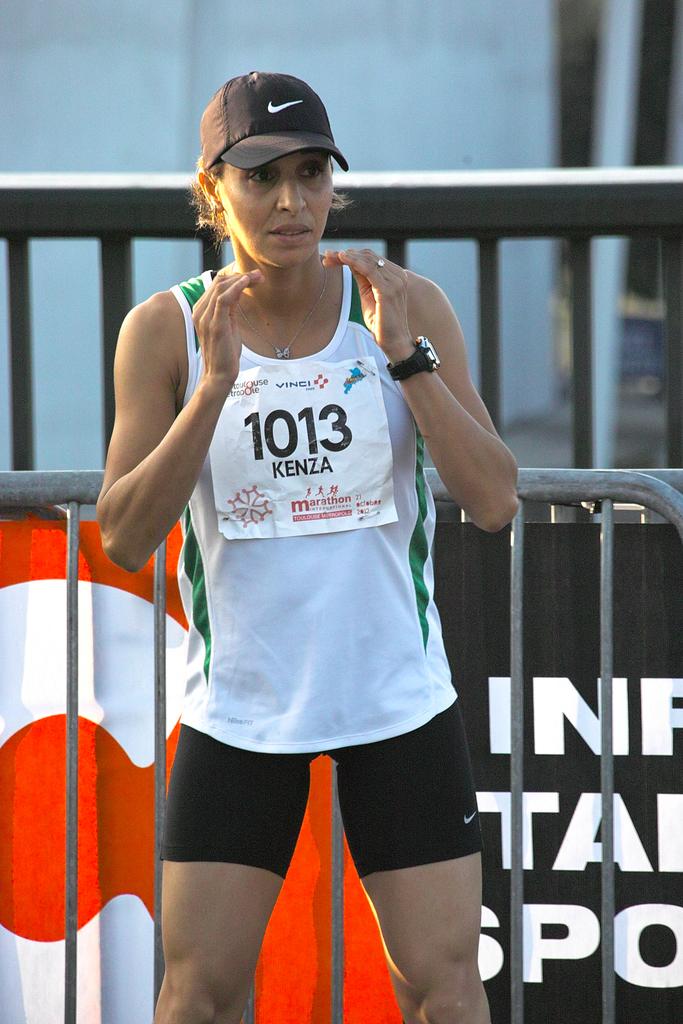What is the runner's number?
Your response must be concise. 1013. What is the runners first name under her number?
Offer a terse response. Kenza. 